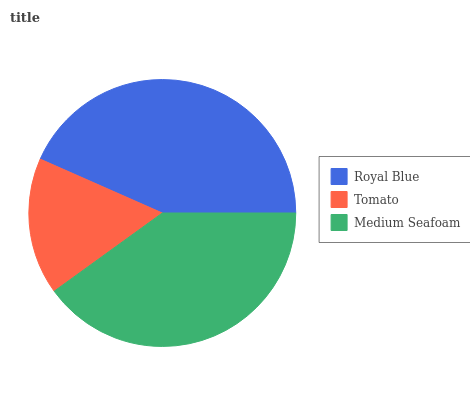Is Tomato the minimum?
Answer yes or no. Yes. Is Royal Blue the maximum?
Answer yes or no. Yes. Is Medium Seafoam the minimum?
Answer yes or no. No. Is Medium Seafoam the maximum?
Answer yes or no. No. Is Medium Seafoam greater than Tomato?
Answer yes or no. Yes. Is Tomato less than Medium Seafoam?
Answer yes or no. Yes. Is Tomato greater than Medium Seafoam?
Answer yes or no. No. Is Medium Seafoam less than Tomato?
Answer yes or no. No. Is Medium Seafoam the high median?
Answer yes or no. Yes. Is Medium Seafoam the low median?
Answer yes or no. Yes. Is Tomato the high median?
Answer yes or no. No. Is Tomato the low median?
Answer yes or no. No. 